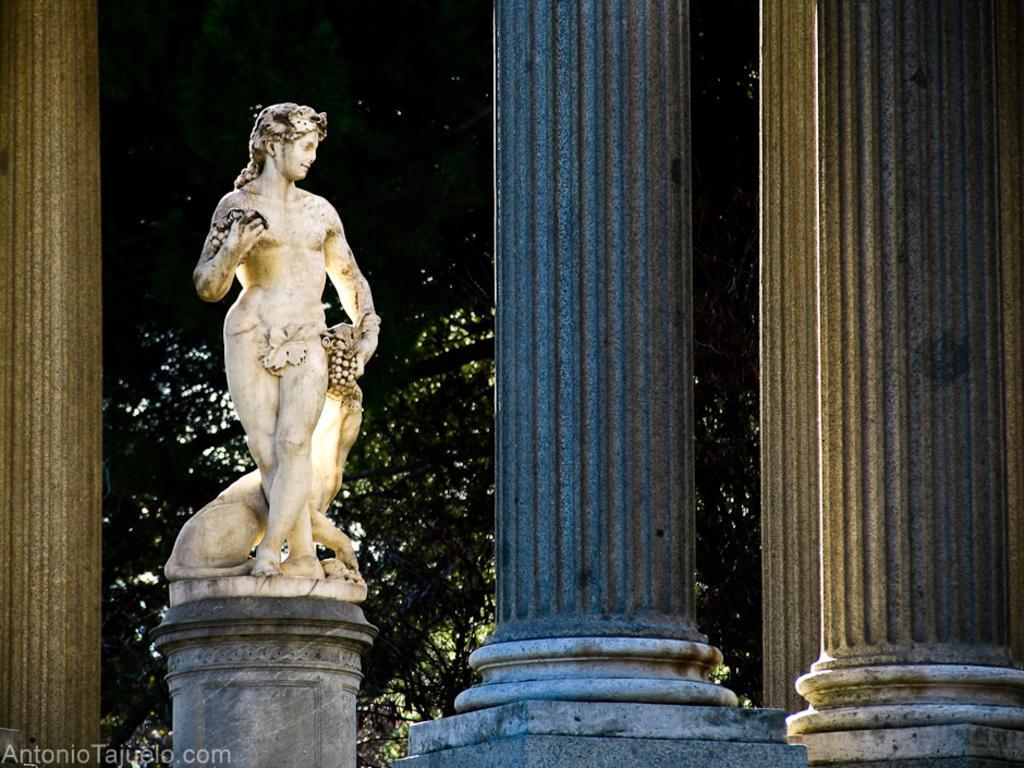Please provide a concise description of this image. In this image we can see sculpture and pillars. In the background of the image there are trees and the sky. On the image there is a watermark. 